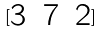<formula> <loc_0><loc_0><loc_500><loc_500>[ \begin{matrix} 3 & 7 & 2 \end{matrix} ]</formula> 